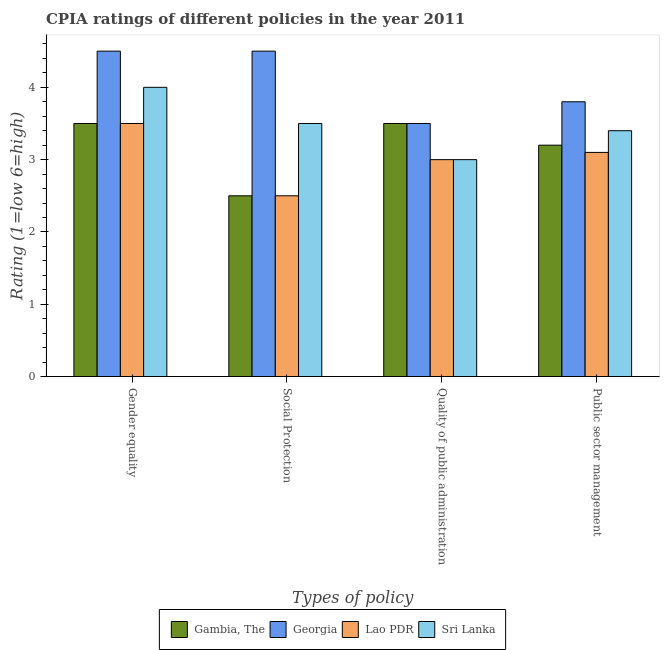How many different coloured bars are there?
Your response must be concise. 4. Are the number of bars per tick equal to the number of legend labels?
Provide a short and direct response. Yes. How many bars are there on the 2nd tick from the left?
Make the answer very short. 4. How many bars are there on the 2nd tick from the right?
Your answer should be compact. 4. What is the label of the 3rd group of bars from the left?
Provide a succinct answer. Quality of public administration. What is the cpia rating of public sector management in Gambia, The?
Ensure brevity in your answer.  3.2. Across all countries, what is the minimum cpia rating of quality of public administration?
Provide a succinct answer. 3. In which country was the cpia rating of gender equality maximum?
Your answer should be compact. Georgia. In which country was the cpia rating of gender equality minimum?
Offer a very short reply. Gambia, The. What is the total cpia rating of quality of public administration in the graph?
Your response must be concise. 13. What is the difference between the cpia rating of social protection in Sri Lanka and that in Gambia, The?
Provide a succinct answer. 1. What is the difference between the cpia rating of public sector management in Gambia, The and the cpia rating of gender equality in Sri Lanka?
Your response must be concise. -0.8. What is the average cpia rating of social protection per country?
Offer a terse response. 3.25. What is the difference between the cpia rating of gender equality and cpia rating of public sector management in Sri Lanka?
Keep it short and to the point. 0.6. In how many countries, is the cpia rating of gender equality greater than 4.4 ?
Make the answer very short. 1. What is the ratio of the cpia rating of social protection in Sri Lanka to that in Gambia, The?
Provide a succinct answer. 1.4. Is the difference between the cpia rating of quality of public administration in Sri Lanka and Georgia greater than the difference between the cpia rating of gender equality in Sri Lanka and Georgia?
Offer a terse response. No. What is the difference between the highest and the second highest cpia rating of public sector management?
Your response must be concise. 0.4. In how many countries, is the cpia rating of social protection greater than the average cpia rating of social protection taken over all countries?
Provide a short and direct response. 2. Is it the case that in every country, the sum of the cpia rating of public sector management and cpia rating of gender equality is greater than the sum of cpia rating of social protection and cpia rating of quality of public administration?
Provide a succinct answer. No. What does the 2nd bar from the left in Quality of public administration represents?
Your answer should be very brief. Georgia. What does the 4th bar from the right in Gender equality represents?
Your answer should be very brief. Gambia, The. Is it the case that in every country, the sum of the cpia rating of gender equality and cpia rating of social protection is greater than the cpia rating of quality of public administration?
Provide a succinct answer. Yes. How many bars are there?
Keep it short and to the point. 16. How many countries are there in the graph?
Keep it short and to the point. 4. What is the difference between two consecutive major ticks on the Y-axis?
Give a very brief answer. 1. Are the values on the major ticks of Y-axis written in scientific E-notation?
Your answer should be compact. No. Does the graph contain grids?
Your answer should be compact. No. What is the title of the graph?
Ensure brevity in your answer.  CPIA ratings of different policies in the year 2011. What is the label or title of the X-axis?
Your answer should be very brief. Types of policy. What is the label or title of the Y-axis?
Give a very brief answer. Rating (1=low 6=high). What is the Rating (1=low 6=high) in Gambia, The in Gender equality?
Make the answer very short. 3.5. What is the Rating (1=low 6=high) in Lao PDR in Gender equality?
Your response must be concise. 3.5. What is the Rating (1=low 6=high) of Gambia, The in Social Protection?
Offer a very short reply. 2.5. What is the Rating (1=low 6=high) in Georgia in Social Protection?
Your answer should be very brief. 4.5. What is the Rating (1=low 6=high) in Sri Lanka in Social Protection?
Provide a short and direct response. 3.5. What is the Rating (1=low 6=high) of Gambia, The in Quality of public administration?
Ensure brevity in your answer.  3.5. What is the Rating (1=low 6=high) in Georgia in Quality of public administration?
Ensure brevity in your answer.  3.5. What is the Rating (1=low 6=high) of Sri Lanka in Quality of public administration?
Your answer should be compact. 3. What is the Rating (1=low 6=high) of Gambia, The in Public sector management?
Give a very brief answer. 3.2. What is the Rating (1=low 6=high) of Georgia in Public sector management?
Make the answer very short. 3.8. Across all Types of policy, what is the maximum Rating (1=low 6=high) of Gambia, The?
Your answer should be compact. 3.5. Across all Types of policy, what is the maximum Rating (1=low 6=high) in Lao PDR?
Give a very brief answer. 3.5. Across all Types of policy, what is the maximum Rating (1=low 6=high) in Sri Lanka?
Ensure brevity in your answer.  4. Across all Types of policy, what is the minimum Rating (1=low 6=high) of Georgia?
Your response must be concise. 3.5. Across all Types of policy, what is the minimum Rating (1=low 6=high) of Lao PDR?
Provide a short and direct response. 2.5. Across all Types of policy, what is the minimum Rating (1=low 6=high) in Sri Lanka?
Provide a short and direct response. 3. What is the total Rating (1=low 6=high) in Gambia, The in the graph?
Give a very brief answer. 12.7. What is the total Rating (1=low 6=high) in Georgia in the graph?
Your response must be concise. 16.3. What is the total Rating (1=low 6=high) of Sri Lanka in the graph?
Make the answer very short. 13.9. What is the difference between the Rating (1=low 6=high) in Georgia in Gender equality and that in Social Protection?
Provide a short and direct response. 0. What is the difference between the Rating (1=low 6=high) in Lao PDR in Gender equality and that in Social Protection?
Your answer should be very brief. 1. What is the difference between the Rating (1=low 6=high) of Sri Lanka in Gender equality and that in Social Protection?
Ensure brevity in your answer.  0.5. What is the difference between the Rating (1=low 6=high) of Gambia, The in Gender equality and that in Quality of public administration?
Make the answer very short. 0. What is the difference between the Rating (1=low 6=high) of Lao PDR in Gender equality and that in Quality of public administration?
Offer a very short reply. 0.5. What is the difference between the Rating (1=low 6=high) of Sri Lanka in Gender equality and that in Quality of public administration?
Ensure brevity in your answer.  1. What is the difference between the Rating (1=low 6=high) of Gambia, The in Gender equality and that in Public sector management?
Provide a short and direct response. 0.3. What is the difference between the Rating (1=low 6=high) in Lao PDR in Gender equality and that in Public sector management?
Your answer should be very brief. 0.4. What is the difference between the Rating (1=low 6=high) of Sri Lanka in Gender equality and that in Public sector management?
Ensure brevity in your answer.  0.6. What is the difference between the Rating (1=low 6=high) of Lao PDR in Social Protection and that in Quality of public administration?
Your response must be concise. -0.5. What is the difference between the Rating (1=low 6=high) of Gambia, The in Social Protection and that in Public sector management?
Provide a short and direct response. -0.7. What is the difference between the Rating (1=low 6=high) in Georgia in Social Protection and that in Public sector management?
Offer a very short reply. 0.7. What is the difference between the Rating (1=low 6=high) in Sri Lanka in Social Protection and that in Public sector management?
Your answer should be very brief. 0.1. What is the difference between the Rating (1=low 6=high) in Lao PDR in Quality of public administration and that in Public sector management?
Your response must be concise. -0.1. What is the difference between the Rating (1=low 6=high) in Sri Lanka in Quality of public administration and that in Public sector management?
Make the answer very short. -0.4. What is the difference between the Rating (1=low 6=high) of Gambia, The in Gender equality and the Rating (1=low 6=high) of Georgia in Social Protection?
Provide a short and direct response. -1. What is the difference between the Rating (1=low 6=high) of Georgia in Gender equality and the Rating (1=low 6=high) of Sri Lanka in Social Protection?
Offer a very short reply. 1. What is the difference between the Rating (1=low 6=high) of Lao PDR in Gender equality and the Rating (1=low 6=high) of Sri Lanka in Social Protection?
Your response must be concise. 0. What is the difference between the Rating (1=low 6=high) in Gambia, The in Gender equality and the Rating (1=low 6=high) in Sri Lanka in Quality of public administration?
Your response must be concise. 0.5. What is the difference between the Rating (1=low 6=high) in Georgia in Gender equality and the Rating (1=low 6=high) in Sri Lanka in Quality of public administration?
Offer a very short reply. 1.5. What is the difference between the Rating (1=low 6=high) of Gambia, The in Gender equality and the Rating (1=low 6=high) of Georgia in Public sector management?
Provide a short and direct response. -0.3. What is the difference between the Rating (1=low 6=high) in Gambia, The in Gender equality and the Rating (1=low 6=high) in Lao PDR in Public sector management?
Offer a terse response. 0.4. What is the difference between the Rating (1=low 6=high) in Gambia, The in Gender equality and the Rating (1=low 6=high) in Sri Lanka in Public sector management?
Make the answer very short. 0.1. What is the difference between the Rating (1=low 6=high) of Georgia in Gender equality and the Rating (1=low 6=high) of Lao PDR in Public sector management?
Your response must be concise. 1.4. What is the difference between the Rating (1=low 6=high) in Georgia in Gender equality and the Rating (1=low 6=high) in Sri Lanka in Public sector management?
Ensure brevity in your answer.  1.1. What is the difference between the Rating (1=low 6=high) in Lao PDR in Gender equality and the Rating (1=low 6=high) in Sri Lanka in Public sector management?
Offer a terse response. 0.1. What is the difference between the Rating (1=low 6=high) of Gambia, The in Social Protection and the Rating (1=low 6=high) of Georgia in Quality of public administration?
Your answer should be compact. -1. What is the difference between the Rating (1=low 6=high) in Gambia, The in Social Protection and the Rating (1=low 6=high) in Lao PDR in Quality of public administration?
Give a very brief answer. -0.5. What is the difference between the Rating (1=low 6=high) of Gambia, The in Social Protection and the Rating (1=low 6=high) of Sri Lanka in Quality of public administration?
Keep it short and to the point. -0.5. What is the difference between the Rating (1=low 6=high) of Georgia in Social Protection and the Rating (1=low 6=high) of Sri Lanka in Quality of public administration?
Keep it short and to the point. 1.5. What is the difference between the Rating (1=low 6=high) of Lao PDR in Social Protection and the Rating (1=low 6=high) of Sri Lanka in Quality of public administration?
Offer a very short reply. -0.5. What is the difference between the Rating (1=low 6=high) in Gambia, The in Social Protection and the Rating (1=low 6=high) in Georgia in Public sector management?
Offer a very short reply. -1.3. What is the difference between the Rating (1=low 6=high) in Gambia, The in Social Protection and the Rating (1=low 6=high) in Lao PDR in Public sector management?
Ensure brevity in your answer.  -0.6. What is the difference between the Rating (1=low 6=high) of Gambia, The in Social Protection and the Rating (1=low 6=high) of Sri Lanka in Public sector management?
Your answer should be very brief. -0.9. What is the difference between the Rating (1=low 6=high) of Georgia in Social Protection and the Rating (1=low 6=high) of Lao PDR in Public sector management?
Give a very brief answer. 1.4. What is the difference between the Rating (1=low 6=high) of Gambia, The in Quality of public administration and the Rating (1=low 6=high) of Lao PDR in Public sector management?
Your answer should be very brief. 0.4. What is the difference between the Rating (1=low 6=high) of Gambia, The in Quality of public administration and the Rating (1=low 6=high) of Sri Lanka in Public sector management?
Your answer should be compact. 0.1. What is the difference between the Rating (1=low 6=high) in Lao PDR in Quality of public administration and the Rating (1=low 6=high) in Sri Lanka in Public sector management?
Give a very brief answer. -0.4. What is the average Rating (1=low 6=high) in Gambia, The per Types of policy?
Your answer should be compact. 3.17. What is the average Rating (1=low 6=high) in Georgia per Types of policy?
Give a very brief answer. 4.08. What is the average Rating (1=low 6=high) in Lao PDR per Types of policy?
Keep it short and to the point. 3.02. What is the average Rating (1=low 6=high) of Sri Lanka per Types of policy?
Make the answer very short. 3.48. What is the difference between the Rating (1=low 6=high) in Gambia, The and Rating (1=low 6=high) in Sri Lanka in Gender equality?
Your answer should be compact. -0.5. What is the difference between the Rating (1=low 6=high) of Georgia and Rating (1=low 6=high) of Sri Lanka in Gender equality?
Offer a terse response. 0.5. What is the difference between the Rating (1=low 6=high) of Lao PDR and Rating (1=low 6=high) of Sri Lanka in Gender equality?
Your response must be concise. -0.5. What is the difference between the Rating (1=low 6=high) in Georgia and Rating (1=low 6=high) in Lao PDR in Social Protection?
Give a very brief answer. 2. What is the difference between the Rating (1=low 6=high) in Georgia and Rating (1=low 6=high) in Sri Lanka in Social Protection?
Offer a very short reply. 1. What is the difference between the Rating (1=low 6=high) of Gambia, The and Rating (1=low 6=high) of Georgia in Quality of public administration?
Offer a terse response. 0. What is the difference between the Rating (1=low 6=high) of Georgia and Rating (1=low 6=high) of Lao PDR in Quality of public administration?
Give a very brief answer. 0.5. What is the difference between the Rating (1=low 6=high) of Lao PDR and Rating (1=low 6=high) of Sri Lanka in Quality of public administration?
Provide a succinct answer. 0. What is the difference between the Rating (1=low 6=high) of Gambia, The and Rating (1=low 6=high) of Georgia in Public sector management?
Give a very brief answer. -0.6. What is the difference between the Rating (1=low 6=high) of Gambia, The and Rating (1=low 6=high) of Lao PDR in Public sector management?
Keep it short and to the point. 0.1. What is the difference between the Rating (1=low 6=high) in Georgia and Rating (1=low 6=high) in Lao PDR in Public sector management?
Your answer should be very brief. 0.7. What is the difference between the Rating (1=low 6=high) of Georgia and Rating (1=low 6=high) of Sri Lanka in Public sector management?
Offer a very short reply. 0.4. What is the ratio of the Rating (1=low 6=high) in Lao PDR in Gender equality to that in Social Protection?
Provide a succinct answer. 1.4. What is the ratio of the Rating (1=low 6=high) in Sri Lanka in Gender equality to that in Social Protection?
Provide a succinct answer. 1.14. What is the ratio of the Rating (1=low 6=high) in Gambia, The in Gender equality to that in Quality of public administration?
Give a very brief answer. 1. What is the ratio of the Rating (1=low 6=high) in Georgia in Gender equality to that in Quality of public administration?
Give a very brief answer. 1.29. What is the ratio of the Rating (1=low 6=high) of Sri Lanka in Gender equality to that in Quality of public administration?
Offer a very short reply. 1.33. What is the ratio of the Rating (1=low 6=high) in Gambia, The in Gender equality to that in Public sector management?
Provide a succinct answer. 1.09. What is the ratio of the Rating (1=low 6=high) in Georgia in Gender equality to that in Public sector management?
Make the answer very short. 1.18. What is the ratio of the Rating (1=low 6=high) in Lao PDR in Gender equality to that in Public sector management?
Provide a short and direct response. 1.13. What is the ratio of the Rating (1=low 6=high) of Sri Lanka in Gender equality to that in Public sector management?
Ensure brevity in your answer.  1.18. What is the ratio of the Rating (1=low 6=high) in Lao PDR in Social Protection to that in Quality of public administration?
Provide a succinct answer. 0.83. What is the ratio of the Rating (1=low 6=high) in Gambia, The in Social Protection to that in Public sector management?
Offer a very short reply. 0.78. What is the ratio of the Rating (1=low 6=high) of Georgia in Social Protection to that in Public sector management?
Your answer should be compact. 1.18. What is the ratio of the Rating (1=low 6=high) in Lao PDR in Social Protection to that in Public sector management?
Provide a short and direct response. 0.81. What is the ratio of the Rating (1=low 6=high) of Sri Lanka in Social Protection to that in Public sector management?
Your answer should be very brief. 1.03. What is the ratio of the Rating (1=low 6=high) of Gambia, The in Quality of public administration to that in Public sector management?
Your answer should be very brief. 1.09. What is the ratio of the Rating (1=low 6=high) of Georgia in Quality of public administration to that in Public sector management?
Provide a succinct answer. 0.92. What is the ratio of the Rating (1=low 6=high) in Sri Lanka in Quality of public administration to that in Public sector management?
Offer a terse response. 0.88. What is the difference between the highest and the second highest Rating (1=low 6=high) of Georgia?
Your response must be concise. 0. What is the difference between the highest and the second highest Rating (1=low 6=high) in Lao PDR?
Make the answer very short. 0.4. What is the difference between the highest and the second highest Rating (1=low 6=high) in Sri Lanka?
Offer a very short reply. 0.5. What is the difference between the highest and the lowest Rating (1=low 6=high) in Gambia, The?
Your answer should be very brief. 1. 